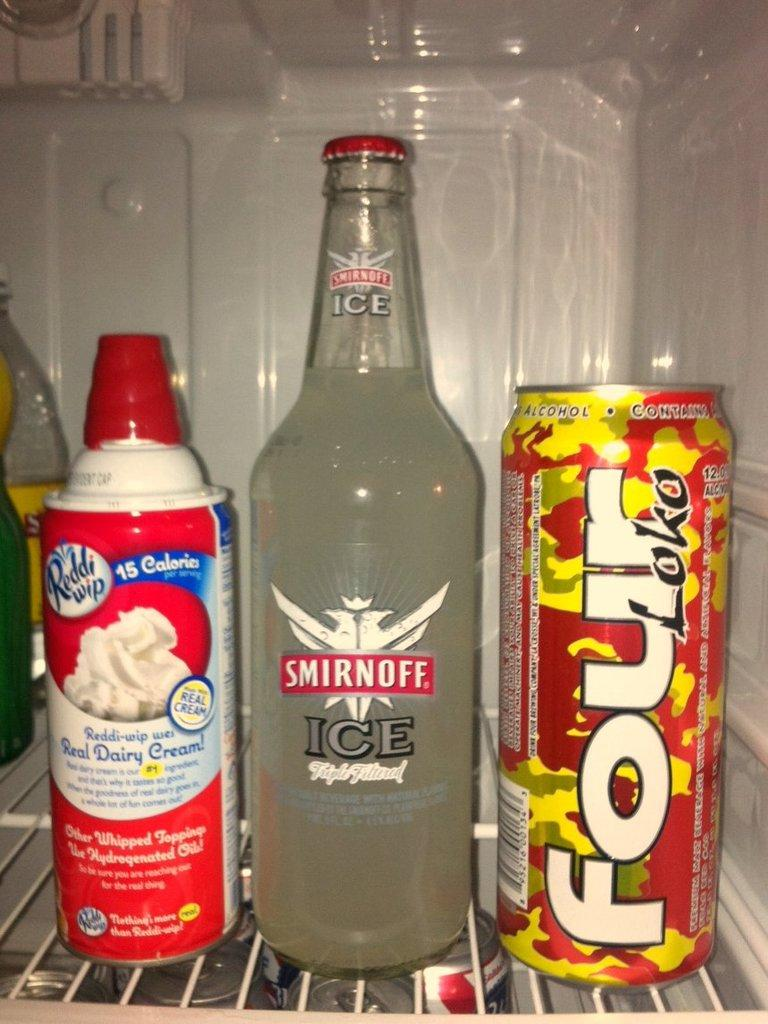<image>
Render a clear and concise summary of the photo. The drink in the middle is a Smirnoff Ice 